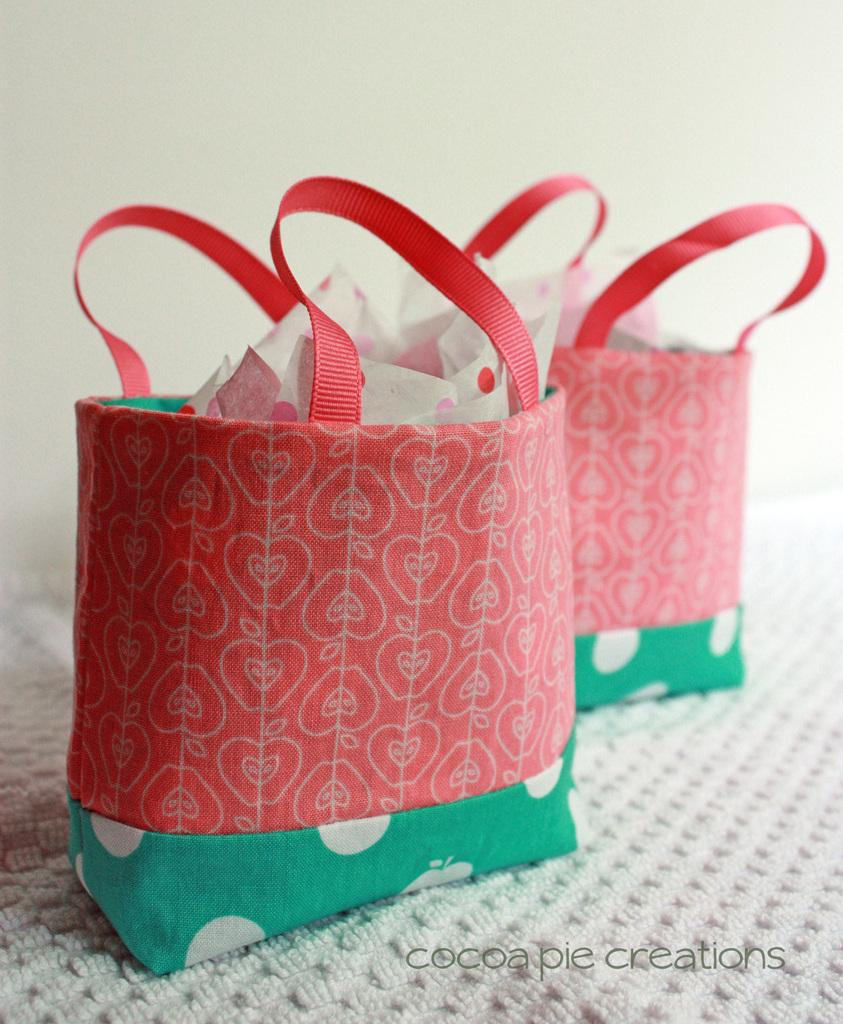How many bags are visible in the image? There are two bags in the image. What colors are the bags? One bag is red, and the other is green. What can be found inside the bags? There are items in the bags. What is under the bags? There is a white mat under the bags. What is behind the bags? There is a white wall behind the bags. Is there a river flowing behind the bags in the image? No, there is no river visible in the image; it only shows two bags with items inside, a white mat, and a white wall. 